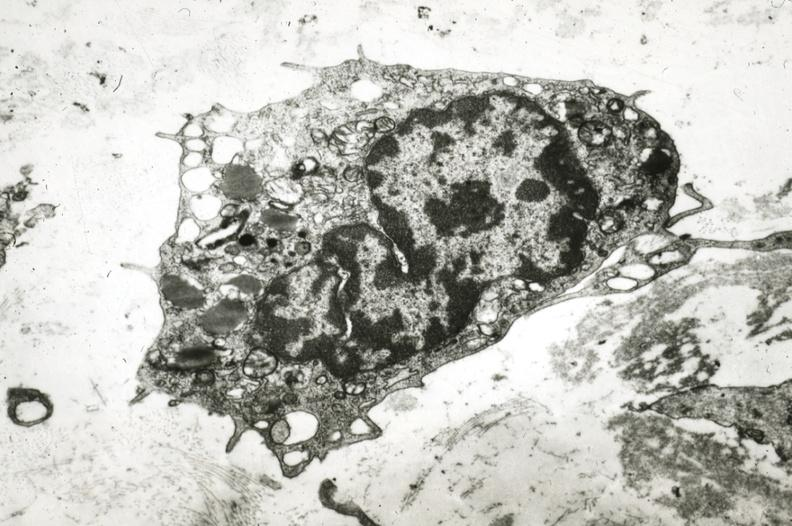where is this?
Answer the question using a single word or phrase. Vasculature 